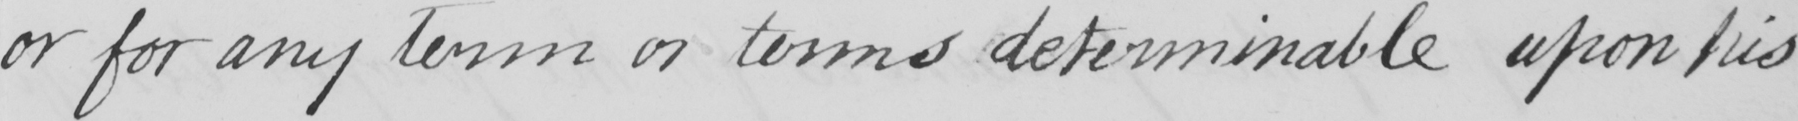Transcribe the text shown in this historical manuscript line. or for any term or terms determinable upon his 